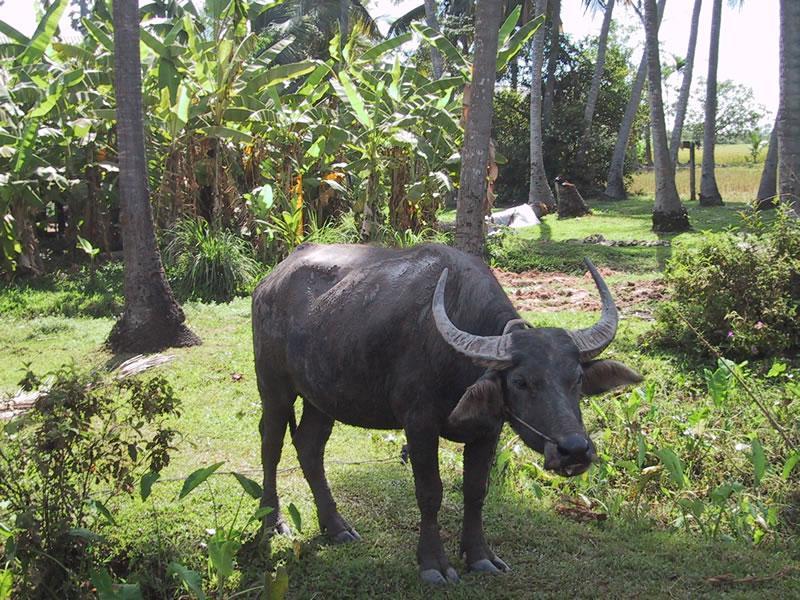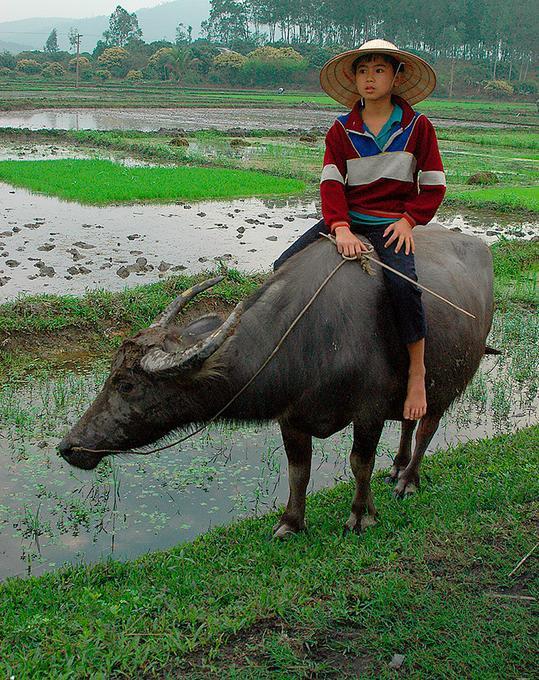The first image is the image on the left, the second image is the image on the right. Considering the images on both sides, is "One image shows only one person, who is wearing a cone-shaped hat and holding a stick, with at least one water buffalo standing in a wet area." valid? Answer yes or no. Yes. The first image is the image on the left, the second image is the image on the right. Assess this claim about the two images: "The left image contains two water buffaloes.". Correct or not? Answer yes or no. No. 